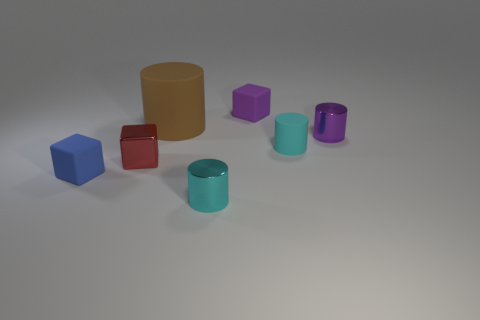What is the material of the tiny thing that is the same color as the tiny matte cylinder?
Offer a terse response. Metal. Are any big yellow matte cubes visible?
Offer a very short reply. No. There is a tiny purple object that is the same shape as the red metal object; what is its material?
Offer a terse response. Rubber. Are there any cubes behind the small purple cylinder?
Your answer should be very brief. Yes. Is the cylinder to the right of the cyan matte cylinder made of the same material as the big brown thing?
Your response must be concise. No. Are there any metallic cylinders that have the same color as the shiny block?
Offer a terse response. No. There is a small blue object; what shape is it?
Keep it short and to the point. Cube. What is the color of the small shiny cylinder behind the rubber thing on the left side of the big brown rubber cylinder?
Your answer should be very brief. Purple. There is a block on the right side of the big brown matte cylinder; what is its size?
Provide a succinct answer. Small. Are there any large brown cylinders made of the same material as the blue object?
Your answer should be very brief. Yes. 